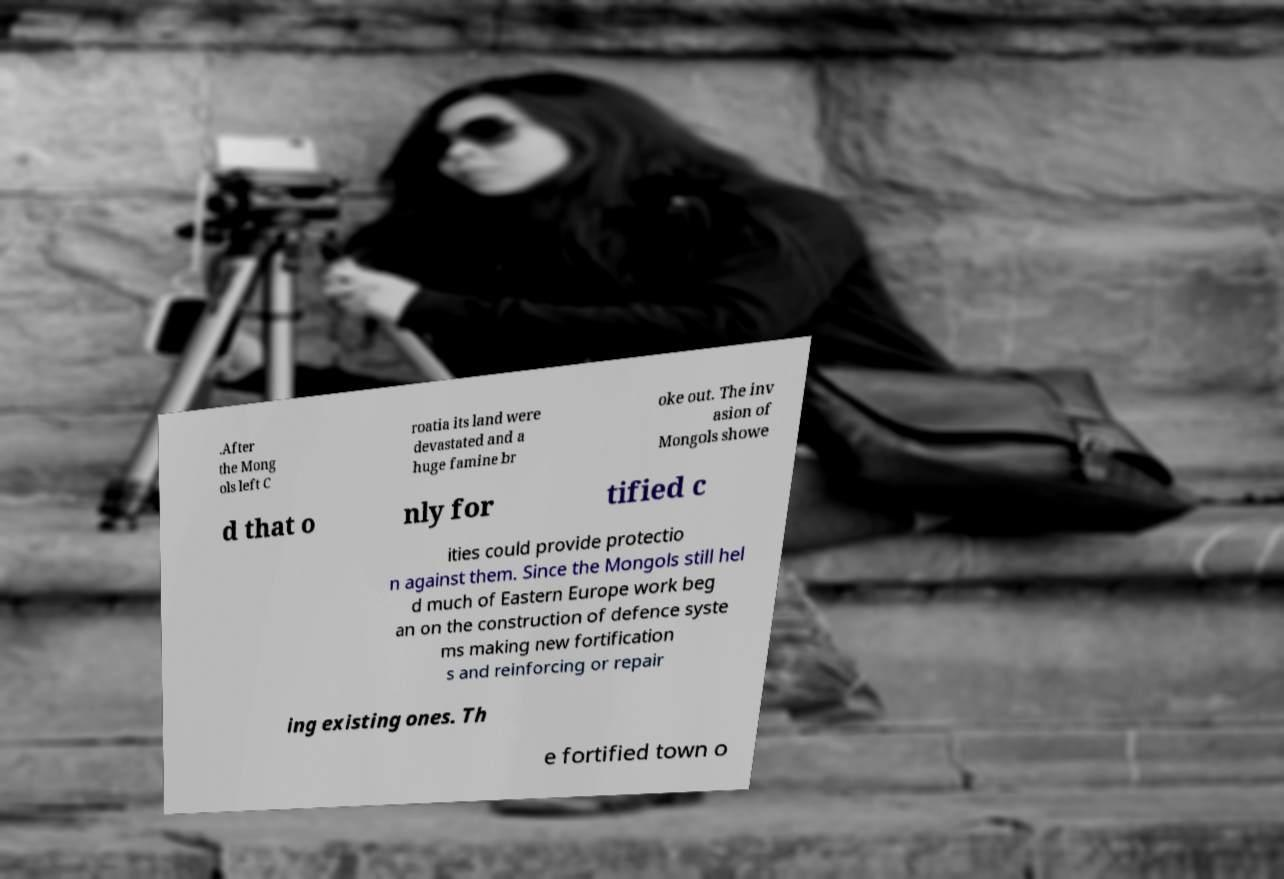What messages or text are displayed in this image? I need them in a readable, typed format. .After the Mong ols left C roatia its land were devastated and a huge famine br oke out. The inv asion of Mongols showe d that o nly for tified c ities could provide protectio n against them. Since the Mongols still hel d much of Eastern Europe work beg an on the construction of defence syste ms making new fortification s and reinforcing or repair ing existing ones. Th e fortified town o 